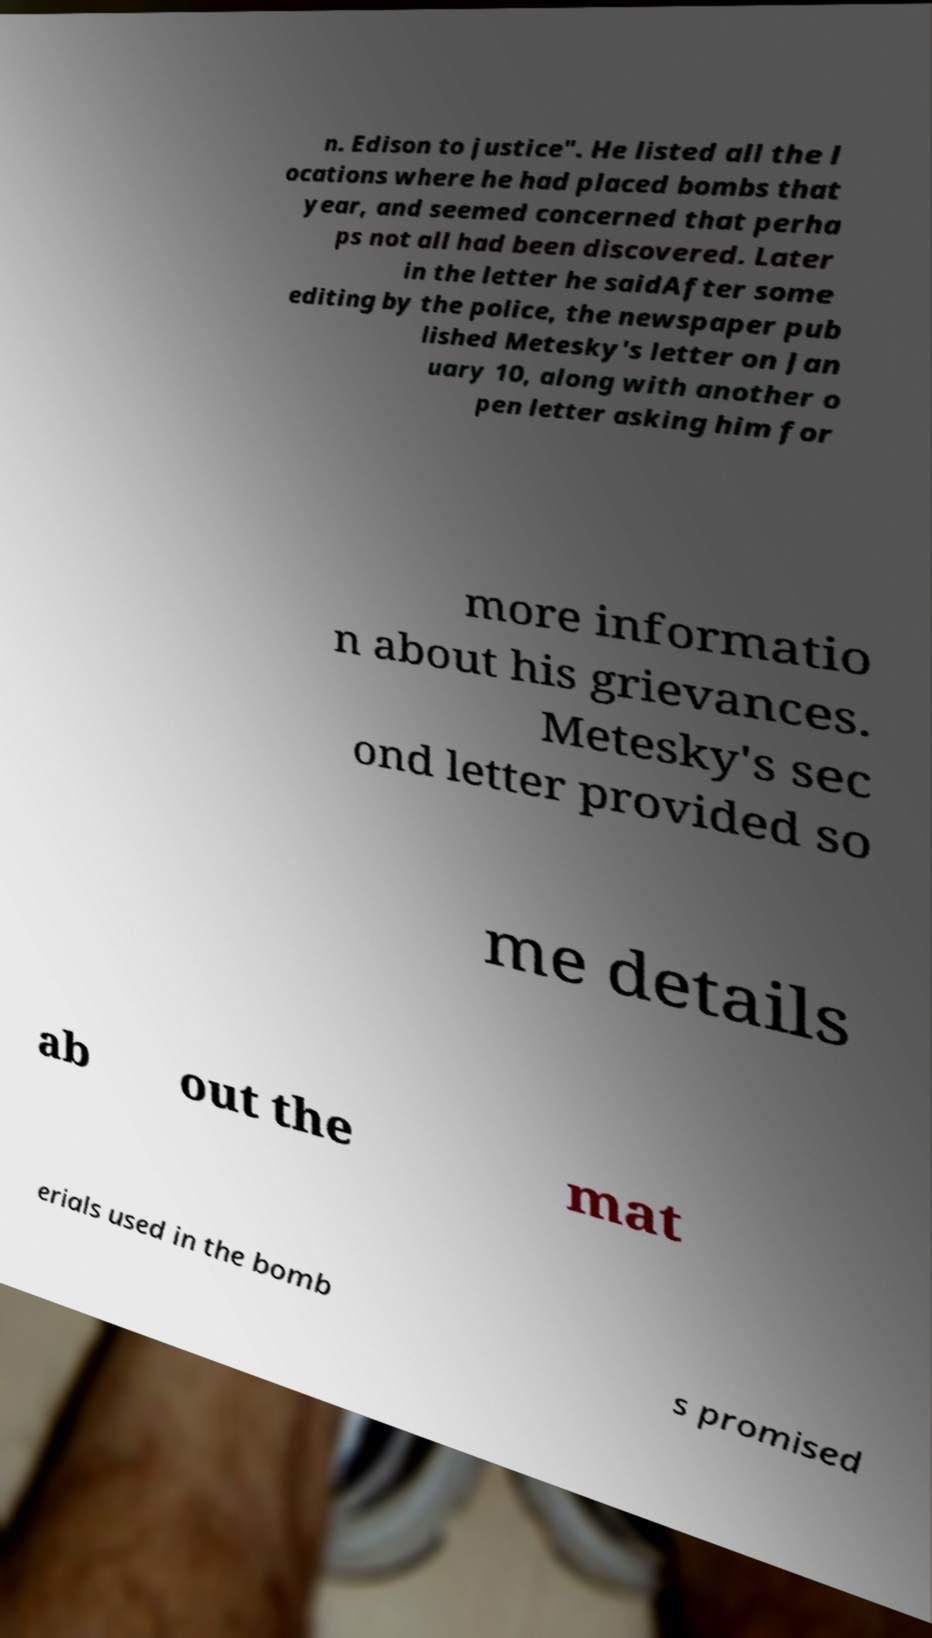Please read and relay the text visible in this image. What does it say? n. Edison to justice". He listed all the l ocations where he had placed bombs that year, and seemed concerned that perha ps not all had been discovered. Later in the letter he saidAfter some editing by the police, the newspaper pub lished Metesky's letter on Jan uary 10, along with another o pen letter asking him for more informatio n about his grievances. Metesky's sec ond letter provided so me details ab out the mat erials used in the bomb s promised 